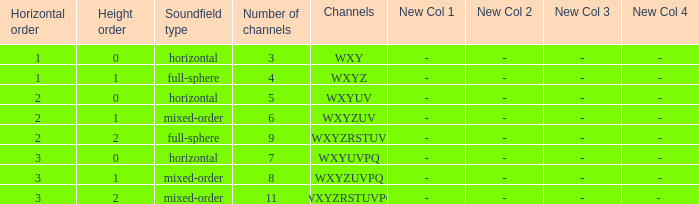If the channels is wxyzrstuvpq, what is the horizontal order? 3.0. 